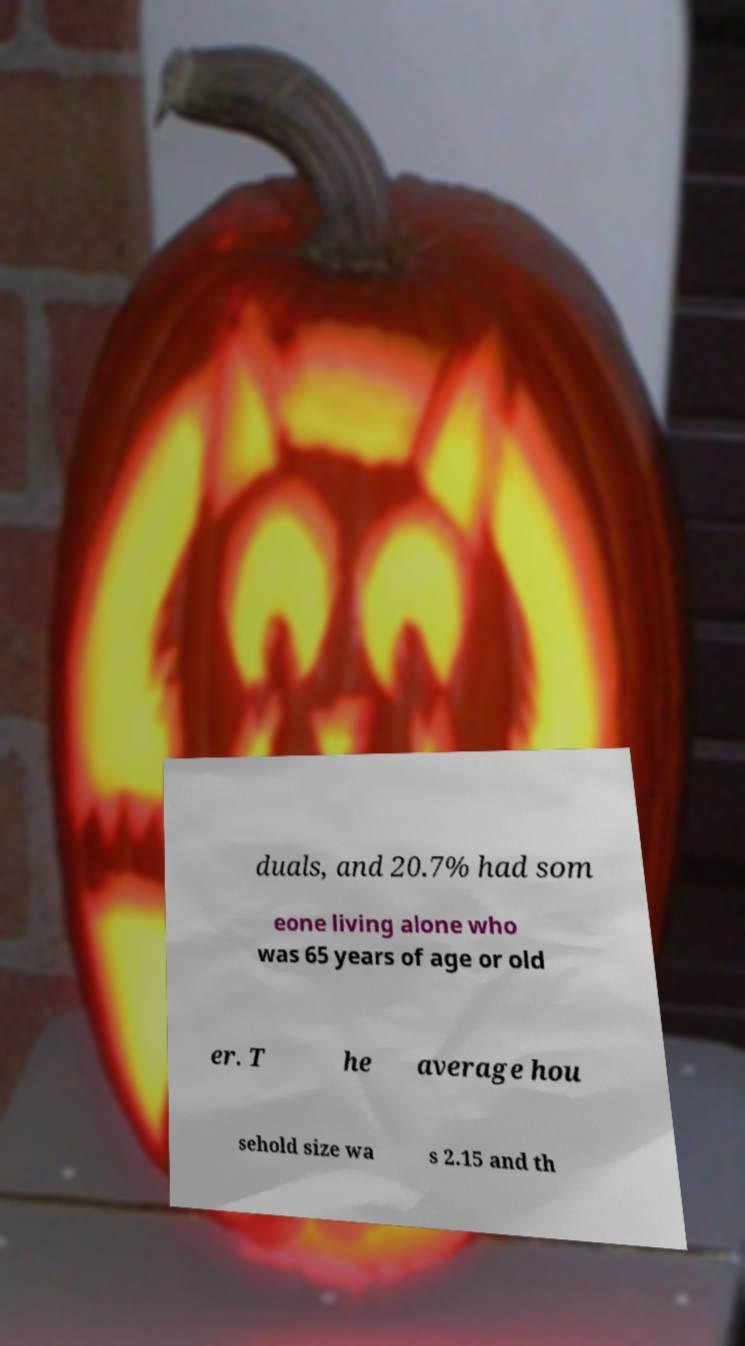Please read and relay the text visible in this image. What does it say? duals, and 20.7% had som eone living alone who was 65 years of age or old er. T he average hou sehold size wa s 2.15 and th 